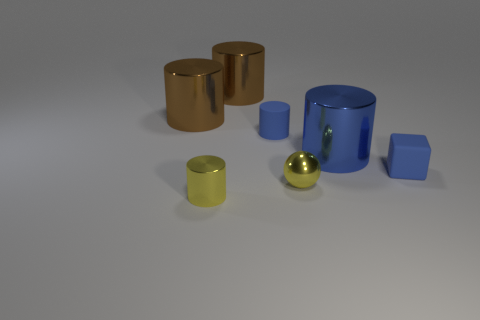What number of other things are there of the same color as the small rubber cylinder?
Make the answer very short. 2. Is there another big blue object that has the same shape as the blue metal object?
Keep it short and to the point. No. Are there any other things that are the same shape as the big blue metallic thing?
Provide a short and direct response. Yes. There is a cylinder that is in front of the shiny ball that is right of the blue matte thing left of the blue matte cube; what is it made of?
Make the answer very short. Metal. Is there a yellow metal object that has the same size as the matte cylinder?
Your answer should be compact. Yes. There is a tiny rubber thing that is to the left of the metal thing that is to the right of the sphere; what color is it?
Offer a terse response. Blue. How many big brown metallic things are there?
Provide a short and direct response. 2. Is the color of the tiny block the same as the small metal cylinder?
Your answer should be compact. No. Is the number of tiny cylinders that are in front of the matte block less than the number of yellow cylinders that are behind the blue metal cylinder?
Your answer should be very brief. No. What color is the small rubber cube?
Provide a short and direct response. Blue. 